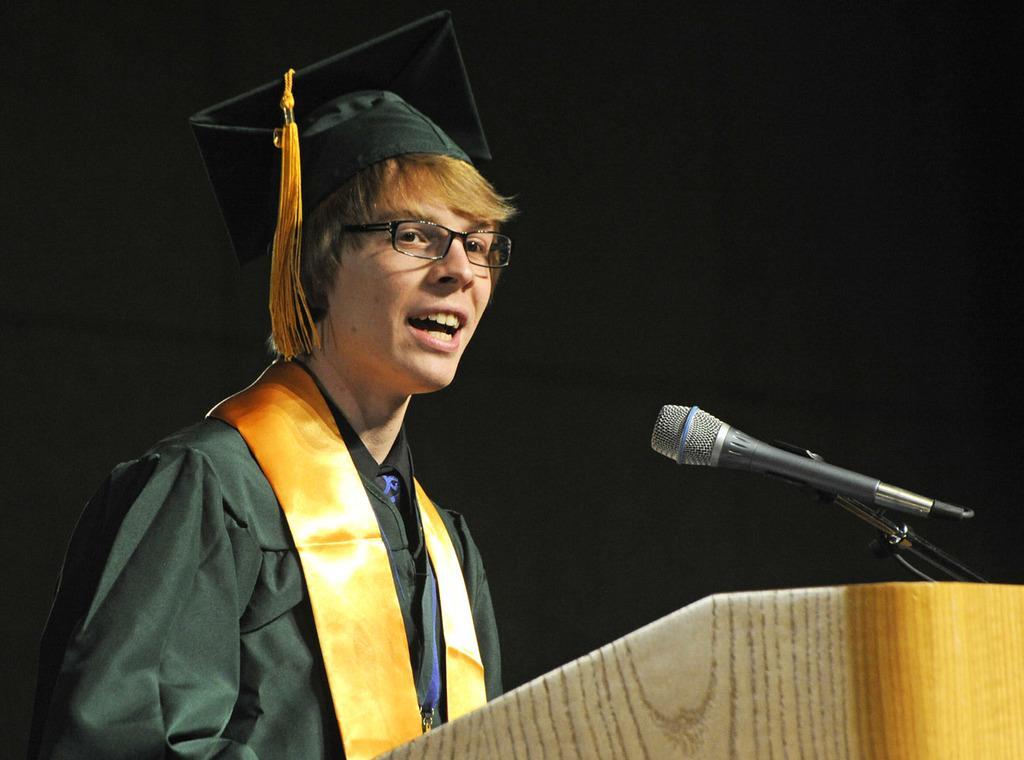Could you give a brief overview of what you see in this image? In this image we can see a person standing in front of the podium, on the podium, we can see a mic and the background is dark. 